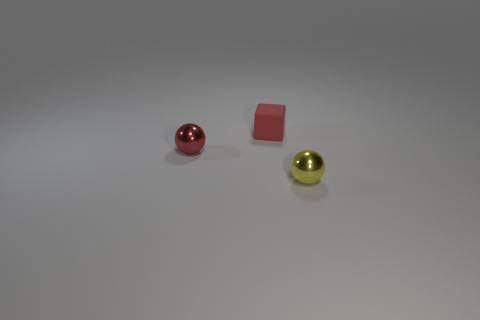Add 1 cubes. How many objects exist? 4 Subtract all spheres. How many objects are left? 1 Add 1 rubber cubes. How many rubber cubes are left? 2 Add 1 small balls. How many small balls exist? 3 Subtract 0 blue balls. How many objects are left? 3 Subtract all tiny red matte objects. Subtract all big blue metallic blocks. How many objects are left? 2 